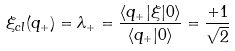<formula> <loc_0><loc_0><loc_500><loc_500>\xi _ { c l } ( q _ { + } ) = \lambda _ { + } = \frac { \langle q _ { + } | \xi | 0 \rangle } { \langle q _ { + } | 0 \rangle } = \frac { + 1 } { \sqrt { 2 } }</formula> 